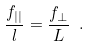Convert formula to latex. <formula><loc_0><loc_0><loc_500><loc_500>\frac { f _ { | | } } { l } = \frac { f _ { \perp } } { L } \ .</formula> 